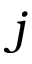Convert formula to latex. <formula><loc_0><loc_0><loc_500><loc_500>j</formula> 